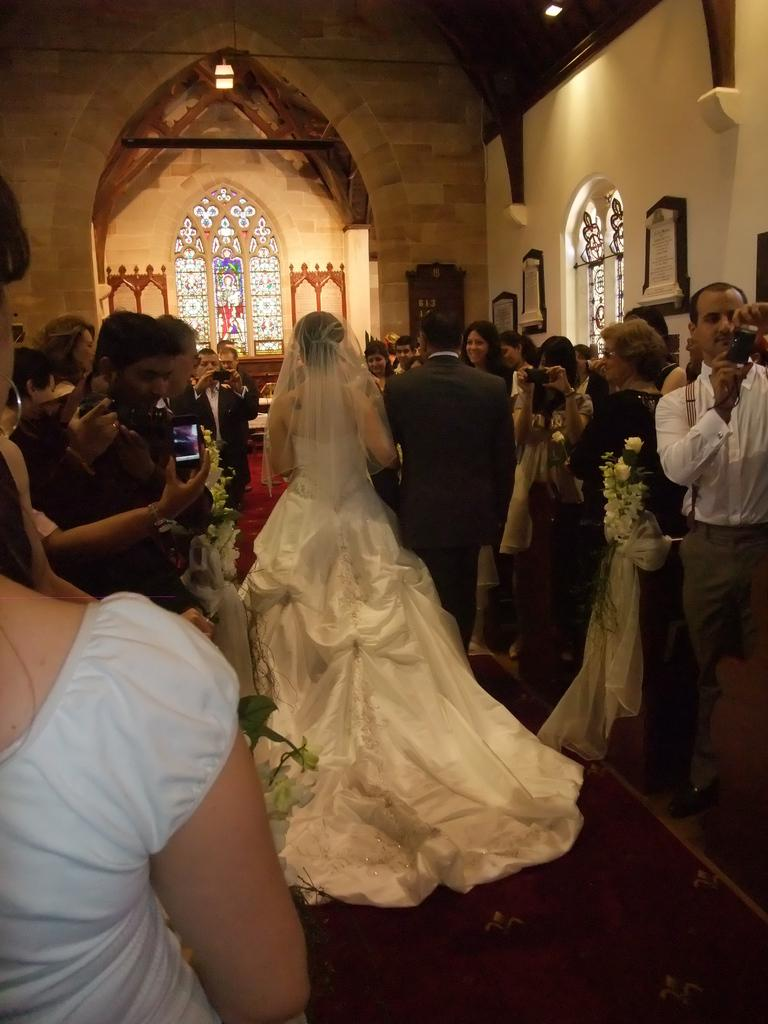How many people are in the image? There are people in the image, but the exact number is not specified. What is the background of the image? There is a wall in the image, and windows are also visible. What is a prominent feature in the image? There is a statue in the image. What type of decorative items can be seen in the image? Photo frames are present in the image. What is the woman wearing in the image? A woman is wearing a white dress in the image. How much eggnog is being served in the image? There is no mention of eggnog in the image, so it cannot be determined how much is being served. Are there any icicles visible in the image? There is no mention of icicles in the image, so it cannot be determined if any are present. 